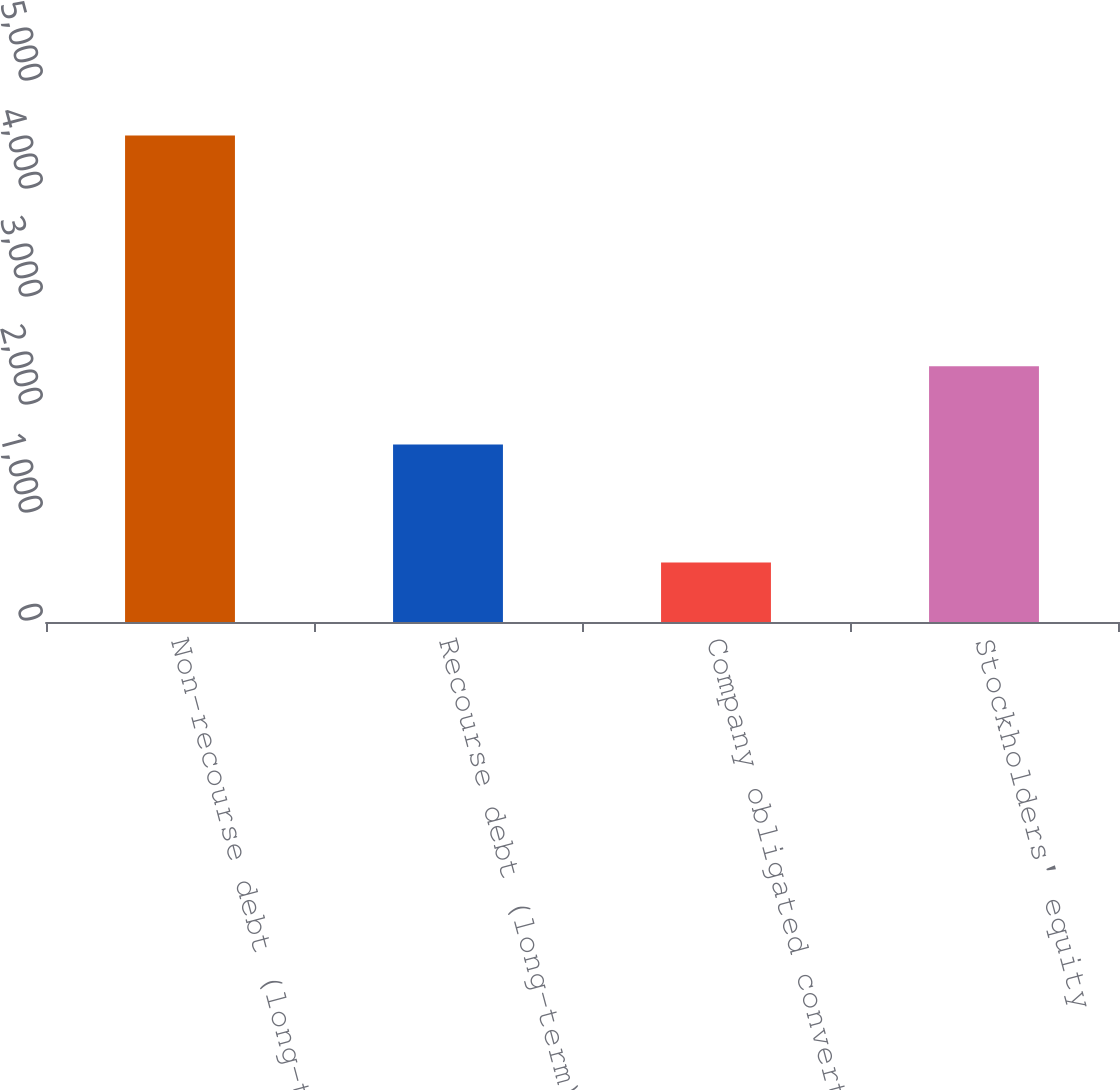Convert chart. <chart><loc_0><loc_0><loc_500><loc_500><bar_chart><fcel>Non-recourse debt (long-term)<fcel>Recourse debt (long-term)<fcel>Company obligated convertible<fcel>Stockholders' equity<nl><fcel>4505<fcel>1644<fcel>550<fcel>2368<nl></chart> 